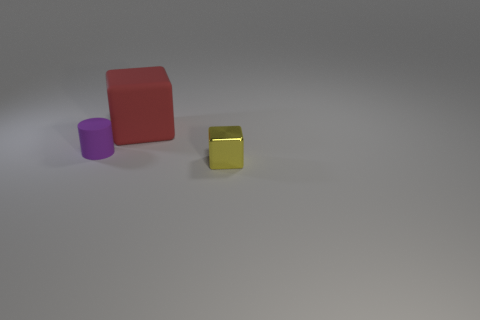There is a thing that is the same size as the purple cylinder; what shape is it?
Your response must be concise. Cube. What number of small objects are to the right of the purple matte thing and on the left side of the red matte thing?
Make the answer very short. 0. Are there fewer red blocks that are to the left of the small yellow object than red objects?
Your answer should be very brief. No. Is there another gray metallic block that has the same size as the shiny block?
Give a very brief answer. No. What is the color of the large cube that is the same material as the purple cylinder?
Your response must be concise. Red. How many tiny purple cylinders are on the right side of the block in front of the purple rubber thing?
Your response must be concise. 0. There is a object that is in front of the matte cube and to the right of the small cylinder; what is its material?
Your answer should be very brief. Metal. Does the tiny object on the right side of the purple matte thing have the same shape as the red matte object?
Your response must be concise. Yes. Is the number of yellow metal cubes less than the number of large cyan objects?
Offer a very short reply. No. How many tiny shiny things have the same color as the tiny metallic block?
Your answer should be very brief. 0. 